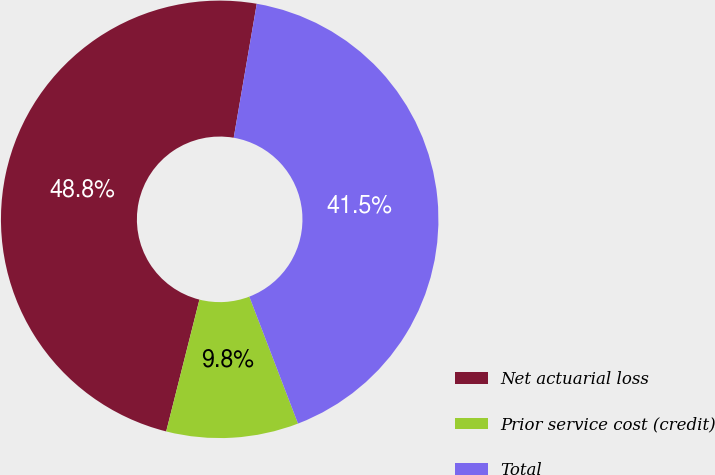Convert chart to OTSL. <chart><loc_0><loc_0><loc_500><loc_500><pie_chart><fcel>Net actuarial loss<fcel>Prior service cost (credit)<fcel>Total<nl><fcel>48.78%<fcel>9.76%<fcel>41.46%<nl></chart> 